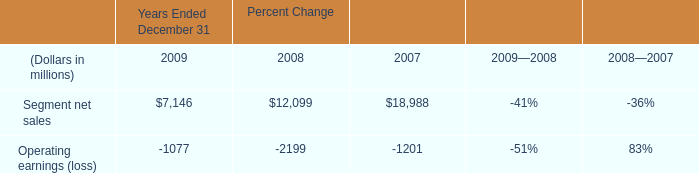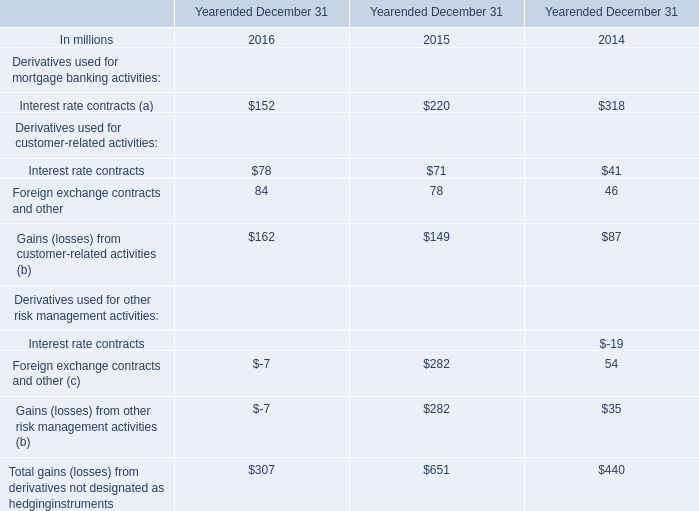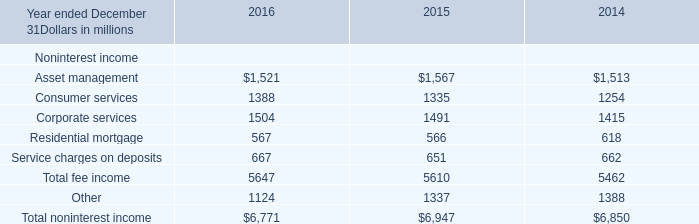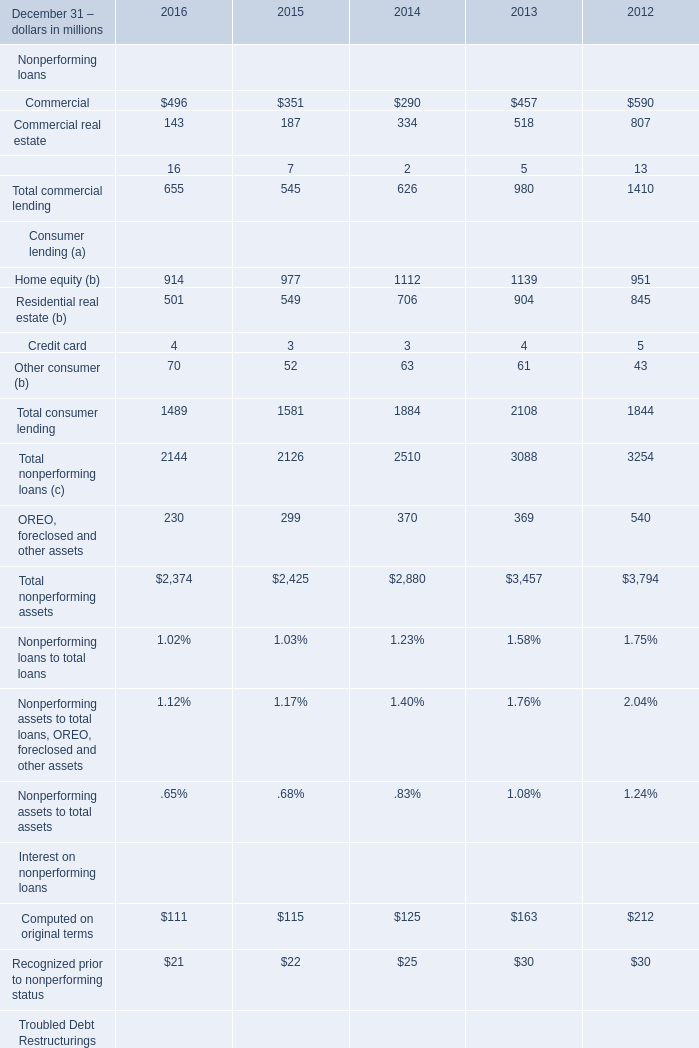What was the total amount of Nonperforming loans in the range of 100 and 500 in 2015? (in million) 
Computations: (351 + 187)
Answer: 538.0. 